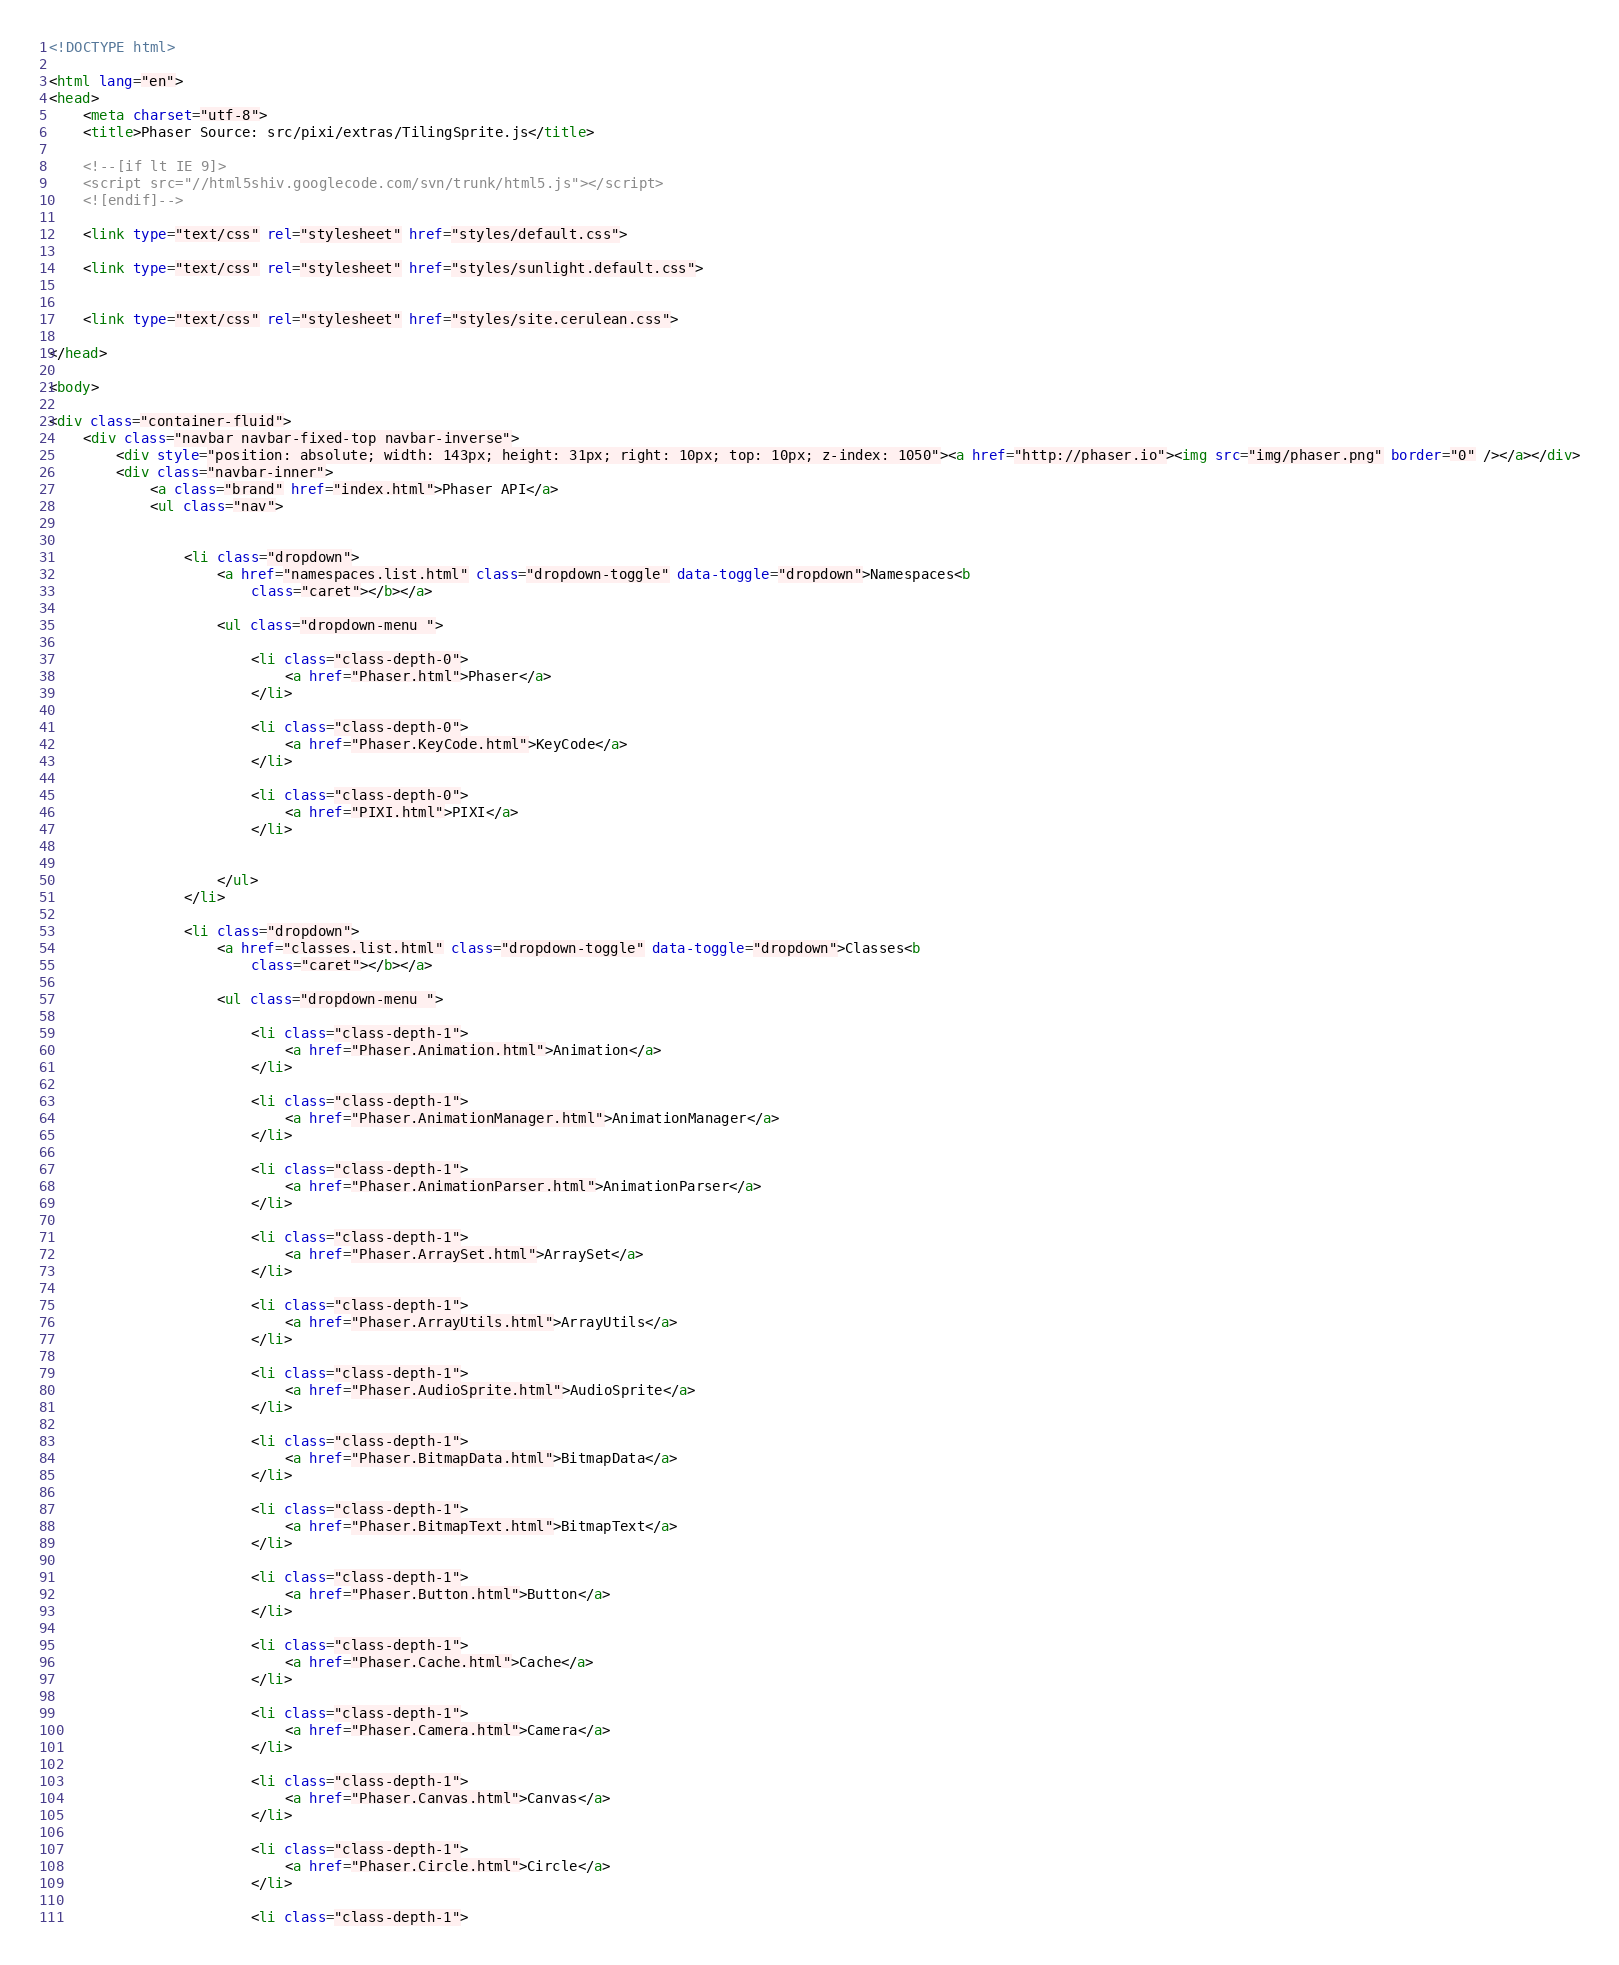Convert code to text. <code><loc_0><loc_0><loc_500><loc_500><_HTML_><!DOCTYPE html>

<html lang="en">
<head>
	<meta charset="utf-8">
	<title>Phaser Source: src/pixi/extras/TilingSprite.js</title>

	<!--[if lt IE 9]>
	<script src="//html5shiv.googlecode.com/svn/trunk/html5.js"></script>
	<![endif]-->

	<link type="text/css" rel="stylesheet" href="styles/default.css">

	<link type="text/css" rel="stylesheet" href="styles/sunlight.default.css">

	
	<link type="text/css" rel="stylesheet" href="styles/site.cerulean.css">
	
</head>

<body>

<div class="container-fluid">
	<div class="navbar navbar-fixed-top navbar-inverse">
		<div style="position: absolute; width: 143px; height: 31px; right: 10px; top: 10px; z-index: 1050"><a href="http://phaser.io"><img src="img/phaser.png" border="0" /></a></div>
		<div class="navbar-inner">
			<a class="brand" href="index.html">Phaser API</a>
			<ul class="nav">

				
				<li class="dropdown">
					<a href="namespaces.list.html" class="dropdown-toggle" data-toggle="dropdown">Namespaces<b
						class="caret"></b></a>

					<ul class="dropdown-menu ">
						
						<li class="class-depth-0">
							<a href="Phaser.html">Phaser</a>
						</li>
						
						<li class="class-depth-0">
							<a href="Phaser.KeyCode.html">KeyCode</a>
						</li>
						
						<li class="class-depth-0">
							<a href="PIXI.html">PIXI</a>
						</li>
						

					</ul>
				</li>
				
				<li class="dropdown">
					<a href="classes.list.html" class="dropdown-toggle" data-toggle="dropdown">Classes<b
						class="caret"></b></a>

					<ul class="dropdown-menu ">
						
						<li class="class-depth-1">
							<a href="Phaser.Animation.html">Animation</a>
						</li>
						
						<li class="class-depth-1">
							<a href="Phaser.AnimationManager.html">AnimationManager</a>
						</li>
						
						<li class="class-depth-1">
							<a href="Phaser.AnimationParser.html">AnimationParser</a>
						</li>
						
						<li class="class-depth-1">
							<a href="Phaser.ArraySet.html">ArraySet</a>
						</li>
						
						<li class="class-depth-1">
							<a href="Phaser.ArrayUtils.html">ArrayUtils</a>
						</li>
						
						<li class="class-depth-1">
							<a href="Phaser.AudioSprite.html">AudioSprite</a>
						</li>
						
						<li class="class-depth-1">
							<a href="Phaser.BitmapData.html">BitmapData</a>
						</li>
						
						<li class="class-depth-1">
							<a href="Phaser.BitmapText.html">BitmapText</a>
						</li>
						
						<li class="class-depth-1">
							<a href="Phaser.Button.html">Button</a>
						</li>
						
						<li class="class-depth-1">
							<a href="Phaser.Cache.html">Cache</a>
						</li>
						
						<li class="class-depth-1">
							<a href="Phaser.Camera.html">Camera</a>
						</li>
						
						<li class="class-depth-1">
							<a href="Phaser.Canvas.html">Canvas</a>
						</li>
						
						<li class="class-depth-1">
							<a href="Phaser.Circle.html">Circle</a>
						</li>
						
						<li class="class-depth-1"></code> 